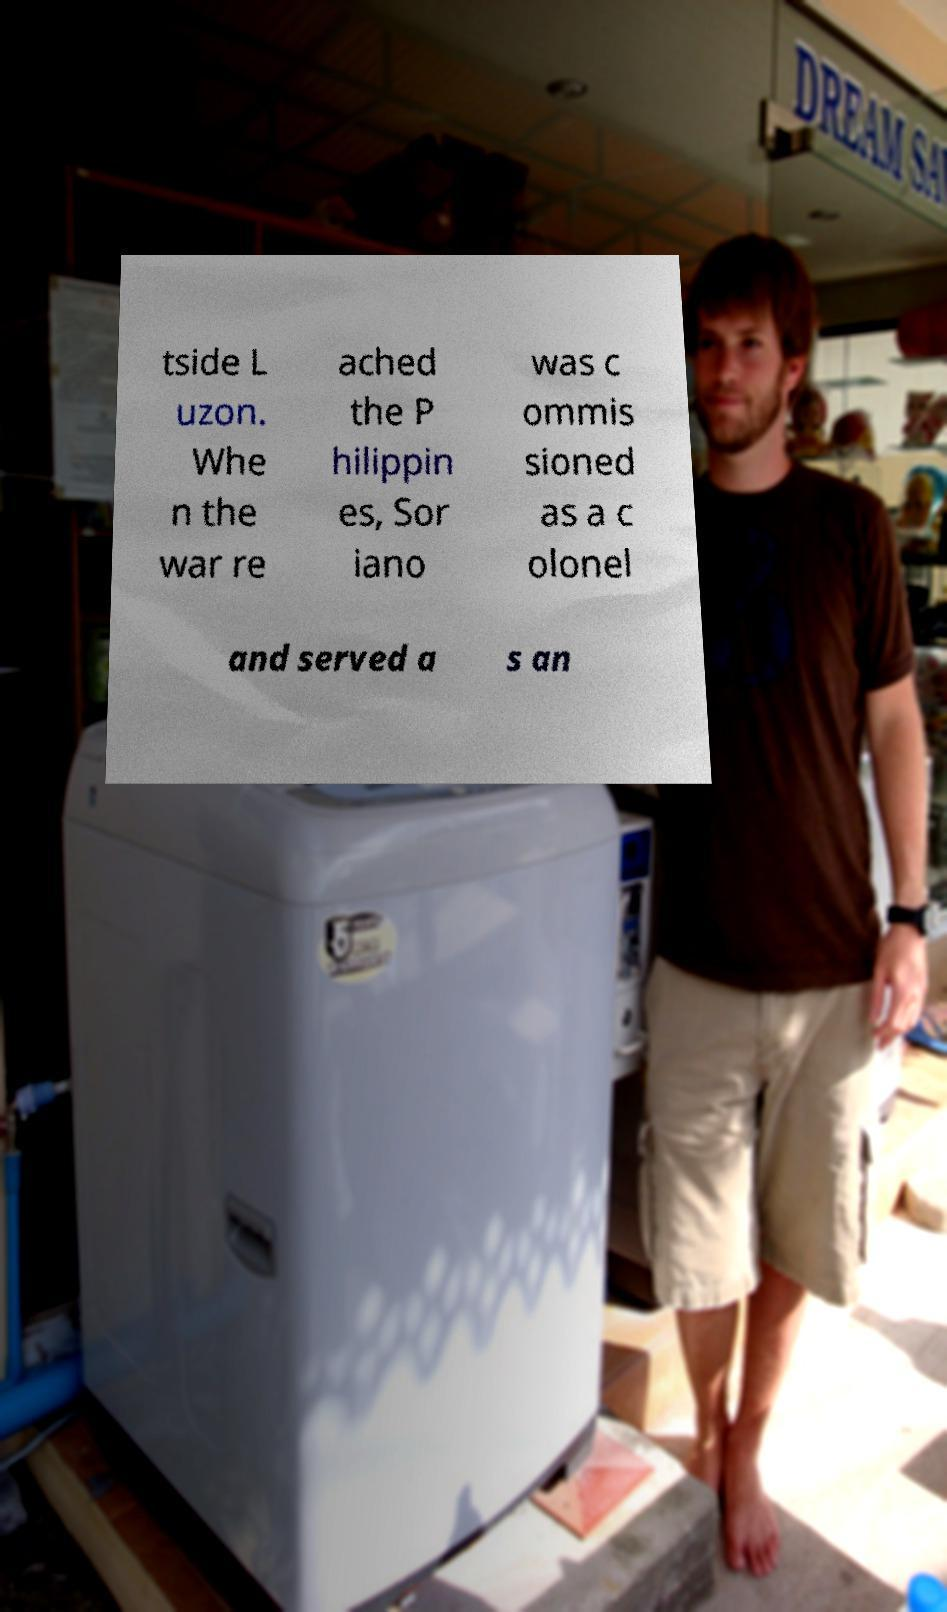Please identify and transcribe the text found in this image. tside L uzon. Whe n the war re ached the P hilippin es, Sor iano was c ommis sioned as a c olonel and served a s an 